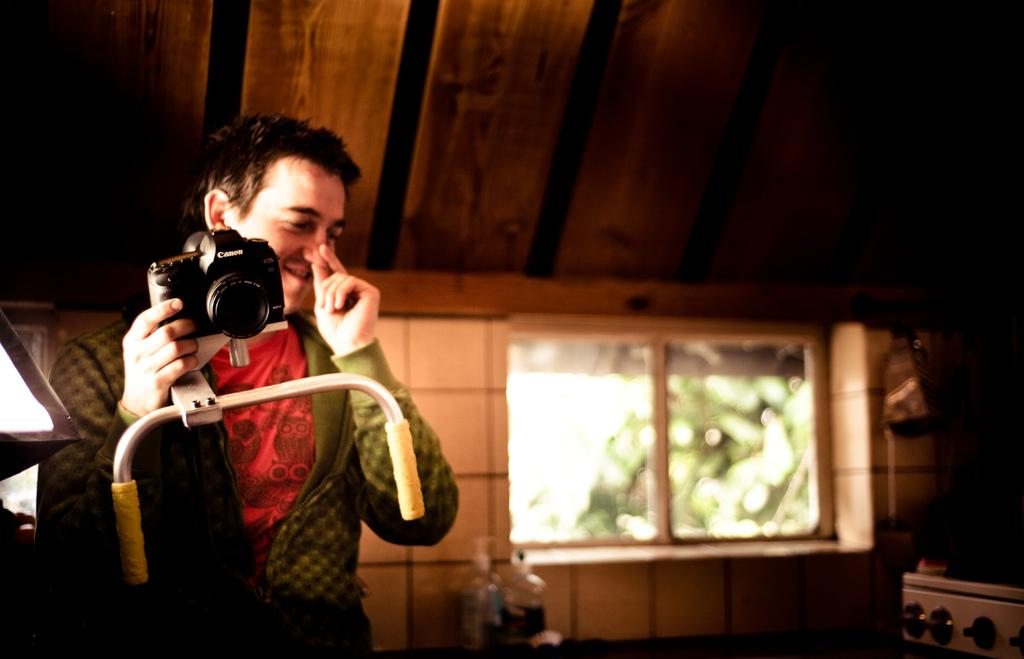What is the main subject of the image? There is a man in the image. What is the man holding in his hand? The man is holding a camera with his hand. What can be seen in the background of the image? There is a wall and a window in the background of the image. What is attached to the camera? There is a camera stand attached to the camera. How many balloons are floating in the air in the image? There are no balloons present in the image. What type of recess can be seen in the image? There is no recess visible in the image. 